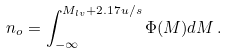<formula> <loc_0><loc_0><loc_500><loc_500>n _ { o } = \int _ { - \infty } ^ { M _ { l v } + 2 . 1 7 u / s } \Phi ( M ) d M \, .</formula> 